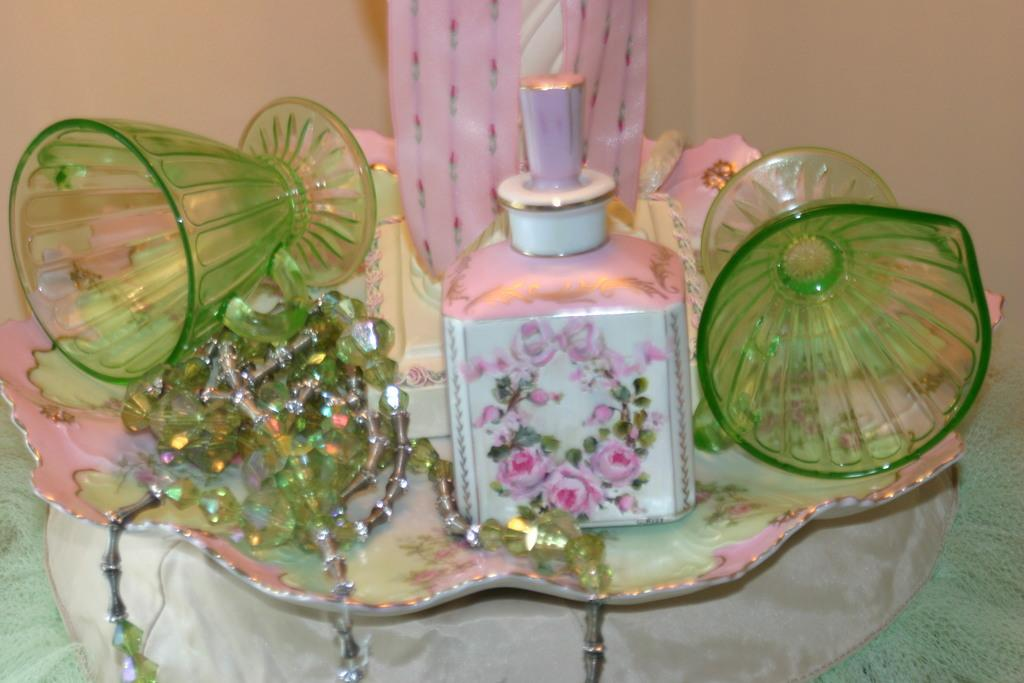What is the main object in the image? There is a perfume bottle in the image. What other objects can be seen in the image? There are two green color glasses and a chain on a plate in the image. Where is the plate located? The plate is on a table. What is visible in the background of the image? There is a plain wall in the background of the image. What year is depicted on the perfume bottle in the image? The year is not visible or mentioned in the image, so it cannot be determined. 